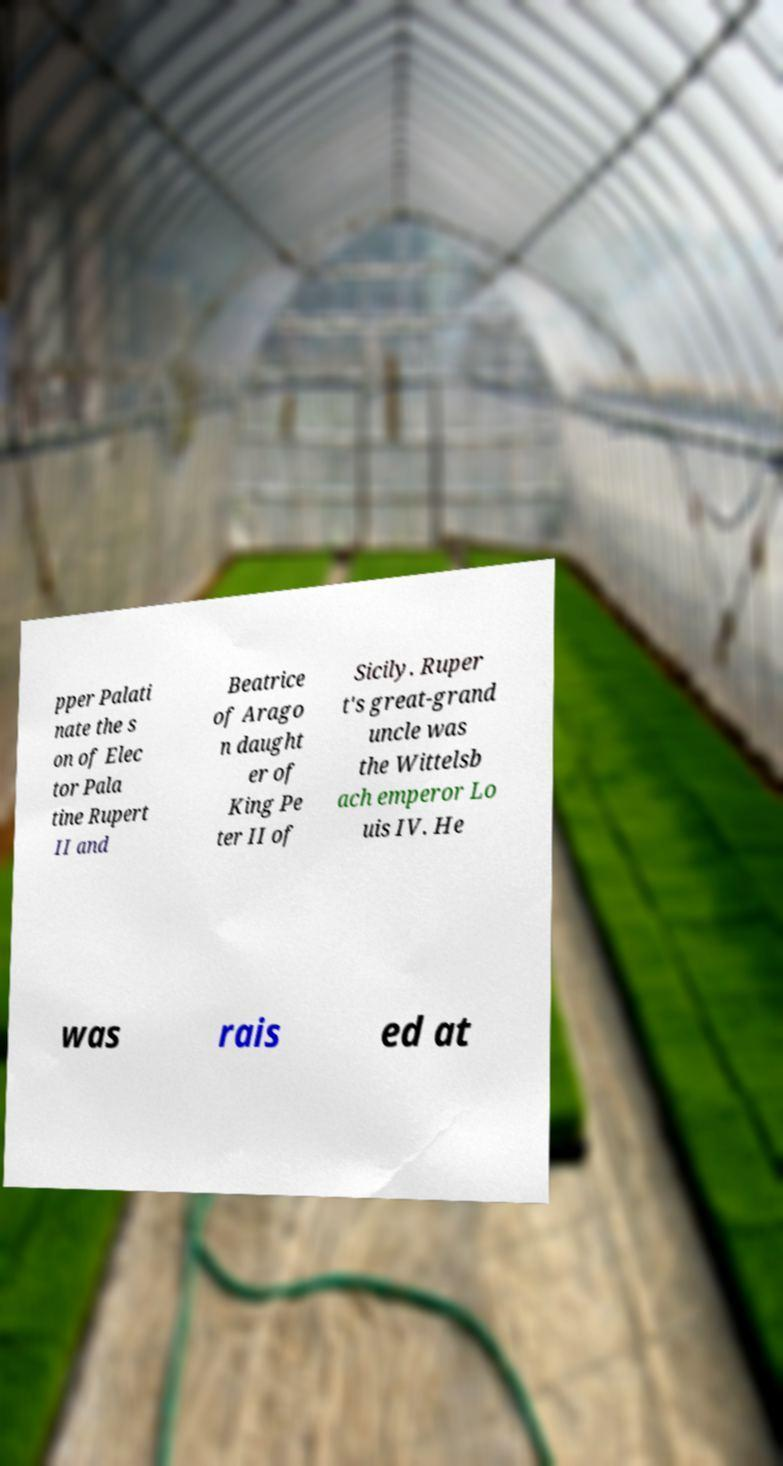I need the written content from this picture converted into text. Can you do that? pper Palati nate the s on of Elec tor Pala tine Rupert II and Beatrice of Arago n daught er of King Pe ter II of Sicily. Ruper t's great-grand uncle was the Wittelsb ach emperor Lo uis IV. He was rais ed at 